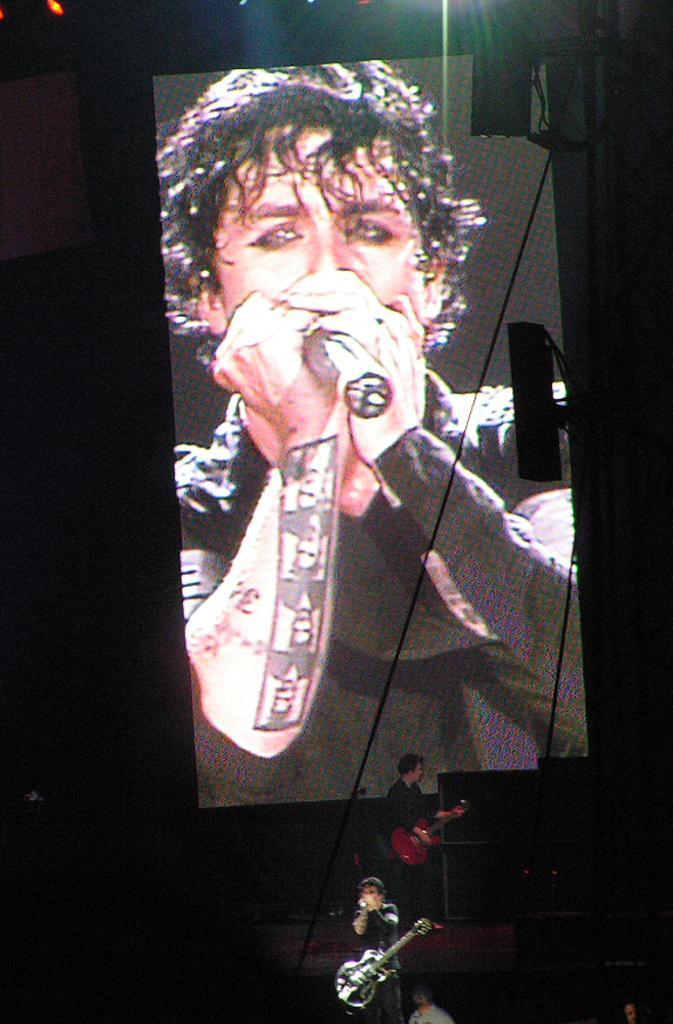Please provide a concise description of this image. This image is clicked in a concert. There are two men in this image. In the front, the man wearing black shirt is singing. In the background, there is a screen in which the same man is projected. 